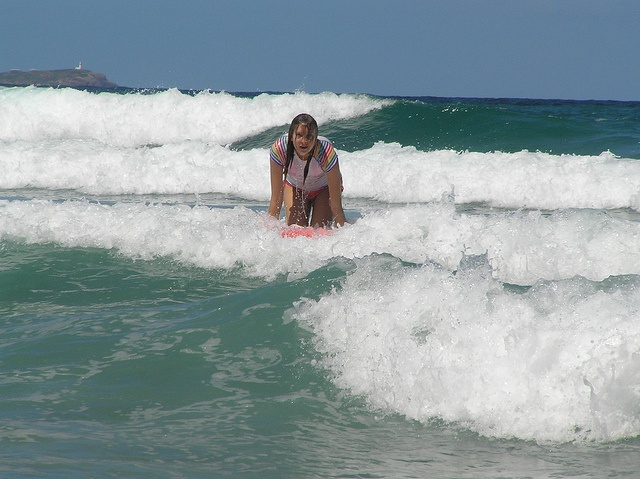Describe the objects in this image and their specific colors. I can see people in gray, maroon, and black tones and surfboard in gray, lightpink, salmon, darkgray, and lightgray tones in this image. 